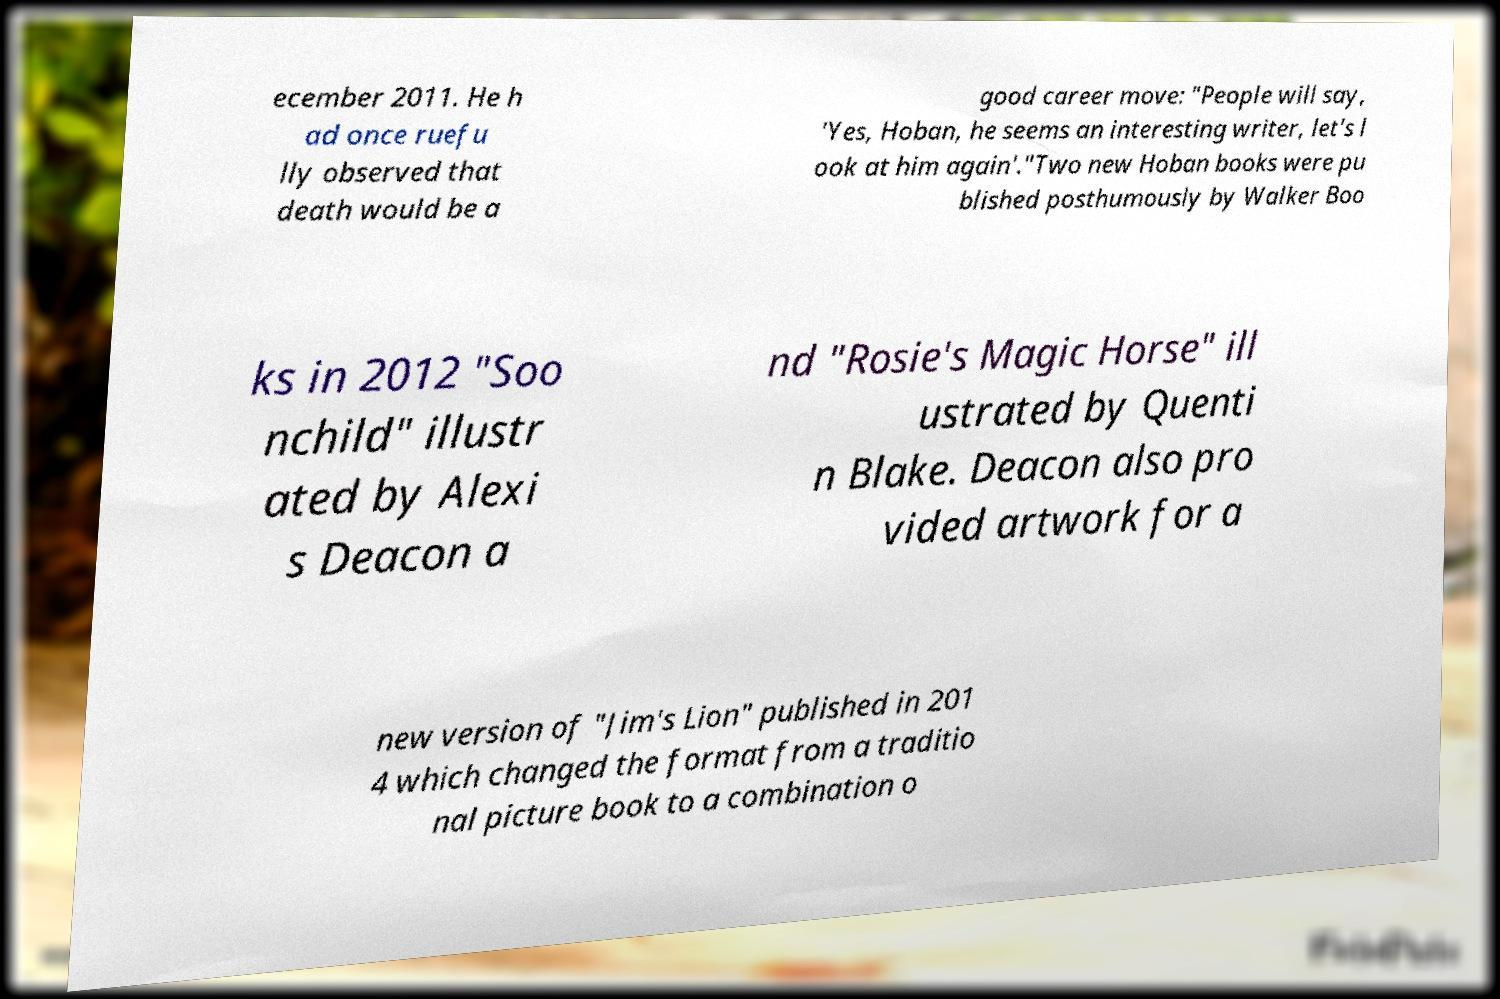Could you assist in decoding the text presented in this image and type it out clearly? ecember 2011. He h ad once ruefu lly observed that death would be a good career move: "People will say, 'Yes, Hoban, he seems an interesting writer, let's l ook at him again'."Two new Hoban books were pu blished posthumously by Walker Boo ks in 2012 "Soo nchild" illustr ated by Alexi s Deacon a nd "Rosie's Magic Horse" ill ustrated by Quenti n Blake. Deacon also pro vided artwork for a new version of "Jim's Lion" published in 201 4 which changed the format from a traditio nal picture book to a combination o 